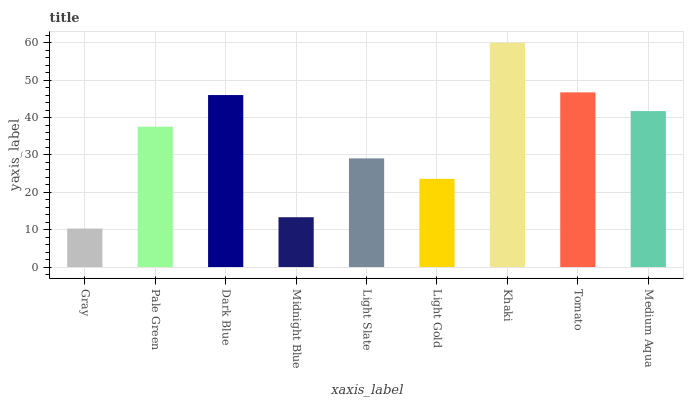Is Gray the minimum?
Answer yes or no. Yes. Is Khaki the maximum?
Answer yes or no. Yes. Is Pale Green the minimum?
Answer yes or no. No. Is Pale Green the maximum?
Answer yes or no. No. Is Pale Green greater than Gray?
Answer yes or no. Yes. Is Gray less than Pale Green?
Answer yes or no. Yes. Is Gray greater than Pale Green?
Answer yes or no. No. Is Pale Green less than Gray?
Answer yes or no. No. Is Pale Green the high median?
Answer yes or no. Yes. Is Pale Green the low median?
Answer yes or no. Yes. Is Gray the high median?
Answer yes or no. No. Is Light Slate the low median?
Answer yes or no. No. 